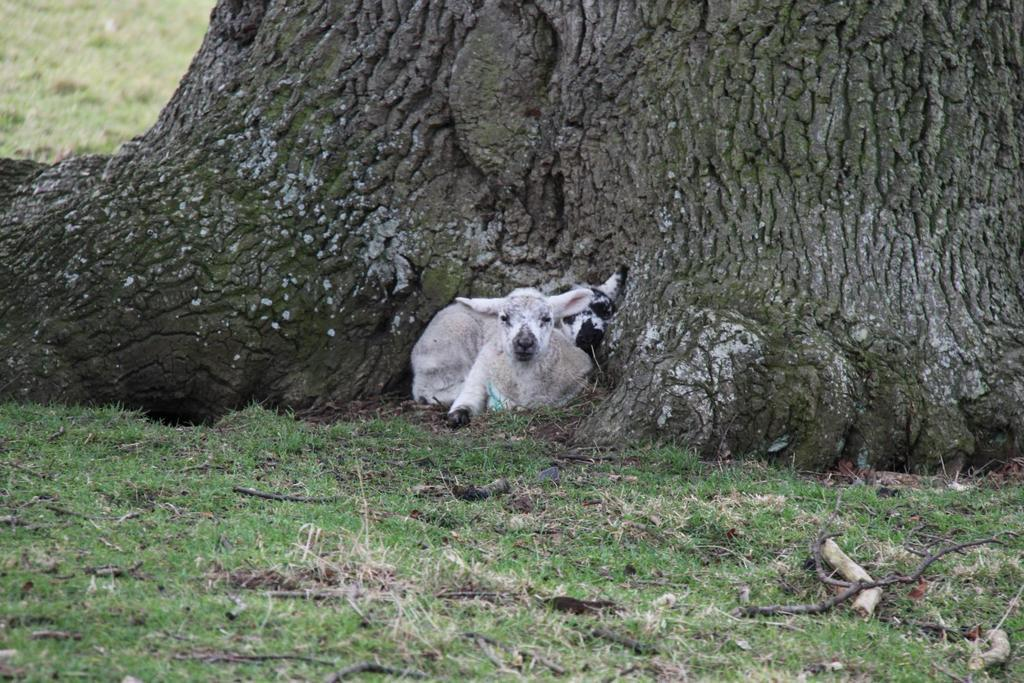What type of vegetation can be seen in the image? There is grass in the image. What kind of animal is present in the image? There is a white-colored animal in the image. What can be seen in the background of the image? There is a tree trunk in the background of the image. Where is the needle located in the image? There is no needle present in the image. What type of map can be seen in the image? There is no map present in the image. 